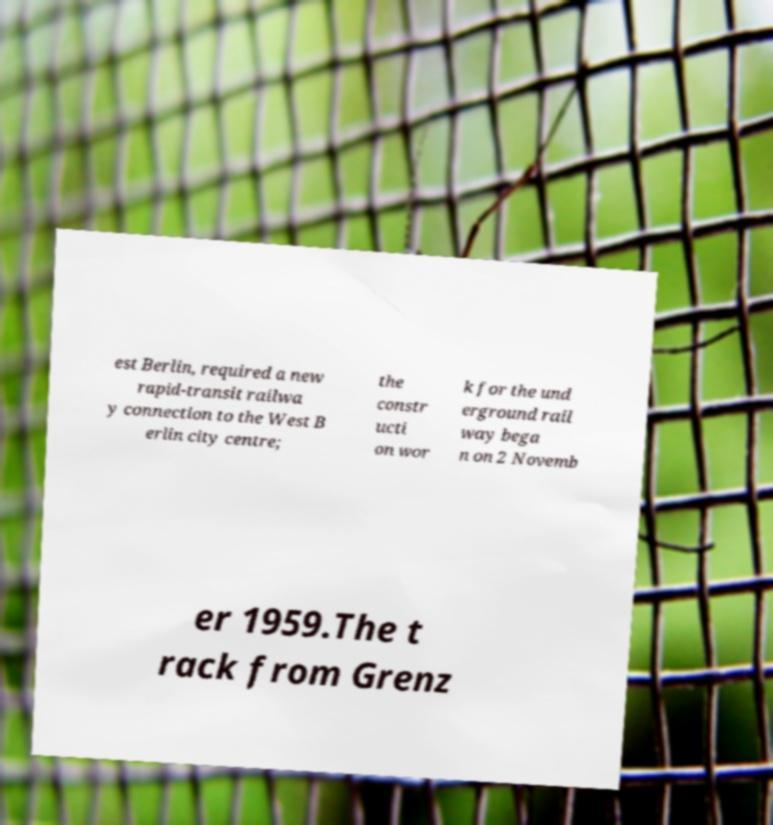Could you assist in decoding the text presented in this image and type it out clearly? est Berlin, required a new rapid-transit railwa y connection to the West B erlin city centre; the constr ucti on wor k for the und erground rail way bega n on 2 Novemb er 1959.The t rack from Grenz 